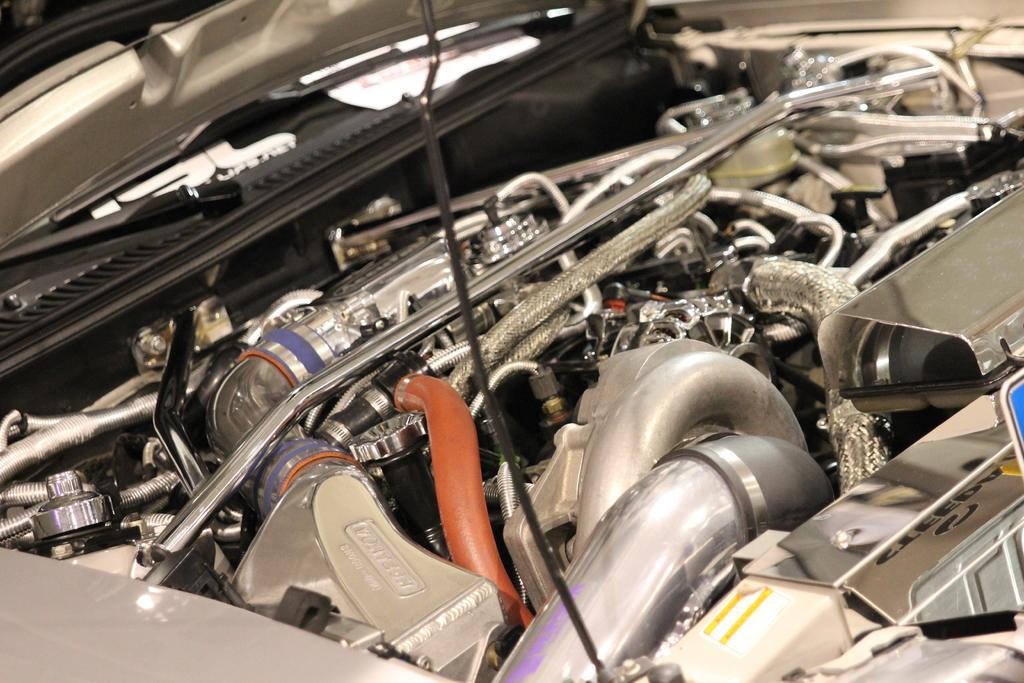What is the main subject of the image? The main subject of the image is a car engine. What specific parts can be seen in the image? There are rods and pipes visible in the image. Are there any other components visible in the image? Yes, there are other unspecified components, referred to as "things," visible in the image. What type of grip can be seen on the rods in the image? There is no grip visible on the rods in the image, as it is a picture of a car engine and not a handheld object. 